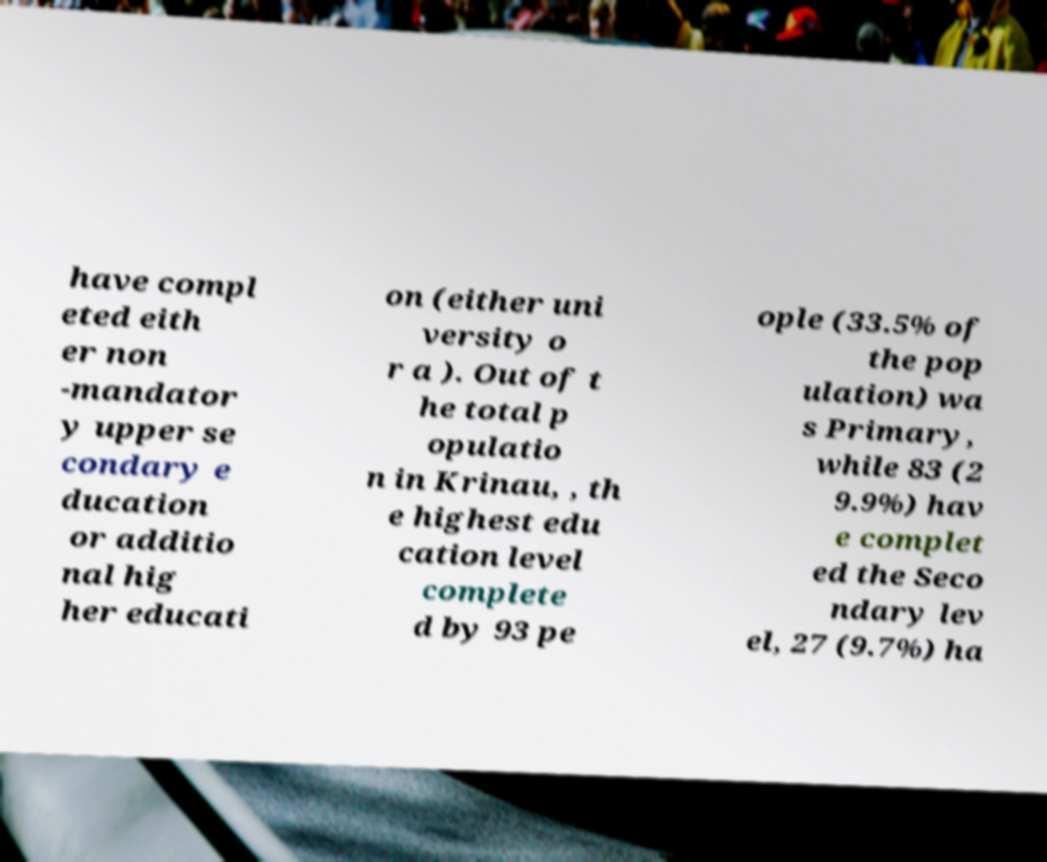Can you accurately transcribe the text from the provided image for me? have compl eted eith er non -mandator y upper se condary e ducation or additio nal hig her educati on (either uni versity o r a ). Out of t he total p opulatio n in Krinau, , th e highest edu cation level complete d by 93 pe ople (33.5% of the pop ulation) wa s Primary, while 83 (2 9.9%) hav e complet ed the Seco ndary lev el, 27 (9.7%) ha 